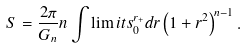Convert formula to latex. <formula><loc_0><loc_0><loc_500><loc_500>S = \frac { 2 \pi } { G _ { n } } n \int \lim i t s _ { 0 } ^ { r _ { + } } d r \left ( 1 + r ^ { 2 } \right ) ^ { n - 1 } .</formula> 